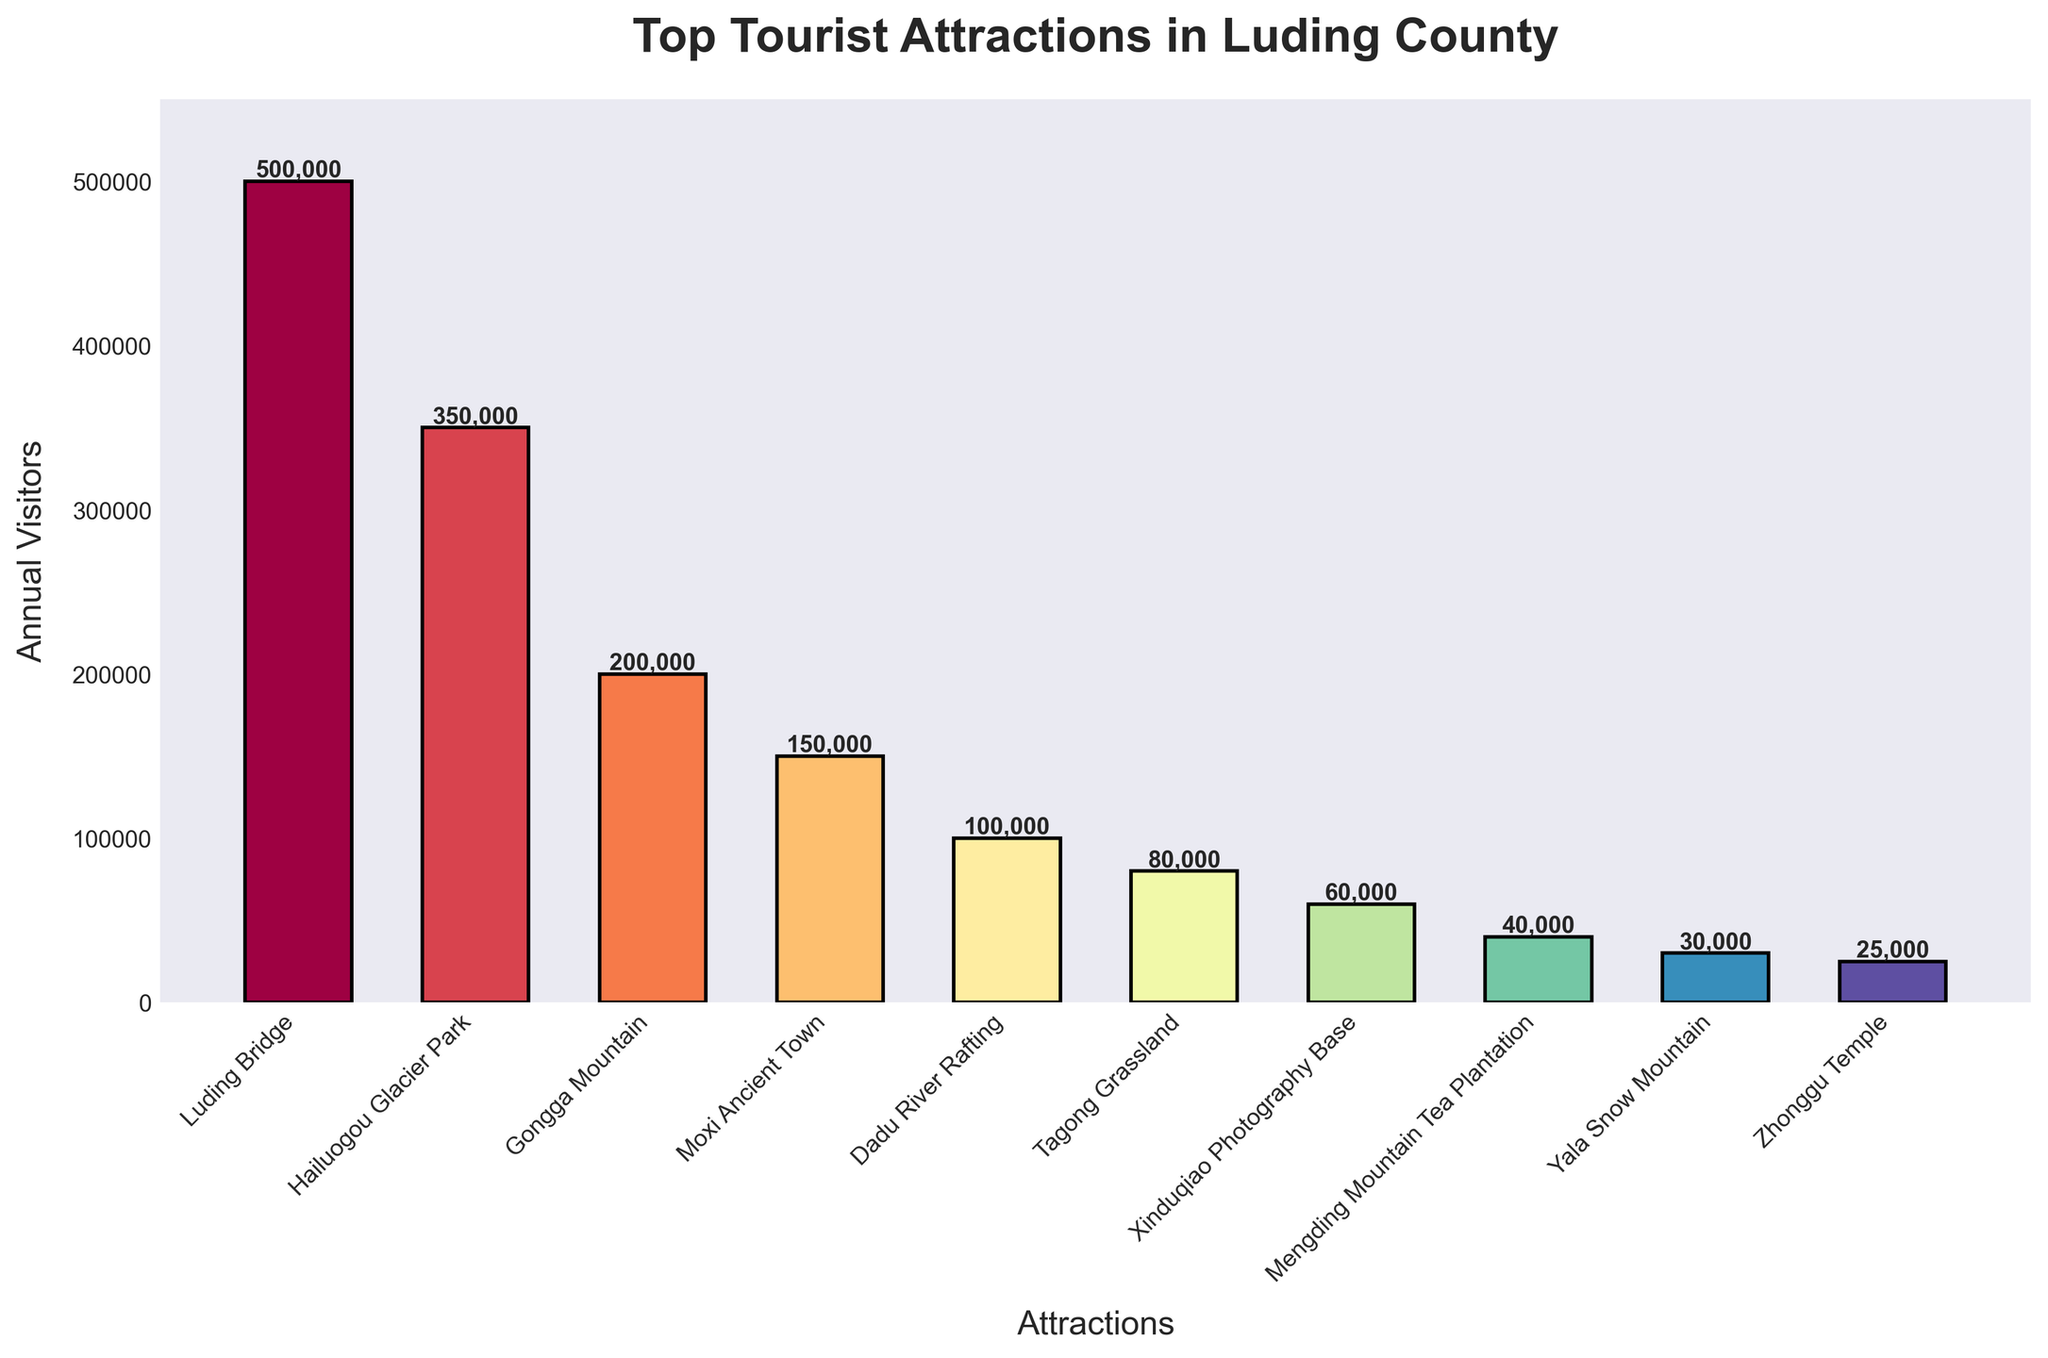Which tourist attraction has the highest number of annual visitors? The bar corresponding to Luding Bridge is the tallest, indicating it has the highest number of annual visitors.
Answer: Luding Bridge Which tourist attraction has the lowest number of annual visitors? The bar corresponding to Zhonggu Temple is the shortest, indicating it has the lowest number of annual visitors.
Answer: Zhonggu Temple How many more annual visitors does Luding Bridge have compared to Hailuogou Glacier Park? The number of annual visitors for Luding Bridge is 500,000 and for Hailuogou Glacier Park is 350,000. The difference is 500,000 - 350,000 = 150,000.
Answer: 150,000 Which tourist attractions have fewer than 100,000 annual visitors? The attractions with bars lower than 100,000 visitors are Tagong Grassland, Xinduqiao Photography Base, Mengding Mountain Tea Plantation, Yala Snow Mountain, and Zhonggu Temple.
Answer: Tagong Grassland, Xinduqiao Photography Base, Mengding Mountain Tea Plantation, Yala Snow Mountain, Zhonggu Temple What is the total number of annual visitors for the three least visited attractions? The number of annual visitors for Yala Snow Mountain is 30,000, Zhonggu Temple is 25,000, and Mengding Mountain Tea Plantation is 40,000. Sum these up: 30,000 + 25,000 + 40,000 = 95,000.
Answer: 95,000 What is the average number of annual visitors across all the attractions? Sum the number of visitors for all attractions (500,000 + 350,000 + 200,000 + 150,000 + 100,000 + 80,000 + 60,000 + 40,000 + 30,000 + 25,000 = 1,535,000). There are 10 attractions, so the average is 1,535,000 / 10 = 153,500.
Answer: 153,500 How does the number of annual visitors for Gongga Mountain compare to Moxi Ancient Town? Gongga Mountain has 200,000 annual visitors and Moxi Ancient Town has 150,000, so Gongga Mountain has 50,000 more visitors than Moxi Ancient Town.
Answer: Gongga Mountain has 50,000 more visitors Which attractions have annual visitors between 50,000 and 100,000? The attractions with visitor numbers within this range are Dadu River Rafting, Tagong Grassland, and Xinduqiao Photography Base.
Answer: Dadu River Rafting, Tagong Grassland, Xinduqiao Photography Base Are there any attractions with exactly 100,000 annual visitors? By examining the bars, Dadu River Rafting has exactly 100,000 annual visitors, identified by the bar height.
Answer: Dadu River Rafting What is the median number of annual visitors for all attractions? Arrange the visitor numbers in ascending order: 25,000, 30,000, 40,000, 60,000, 80,000, 100,000, 150,000, 200,000, 350,000, 500,000. The median is the average of the 5th and 6th numbers: (80,000 + 100,000) / 2 = 90,000.
Answer: 90,000 